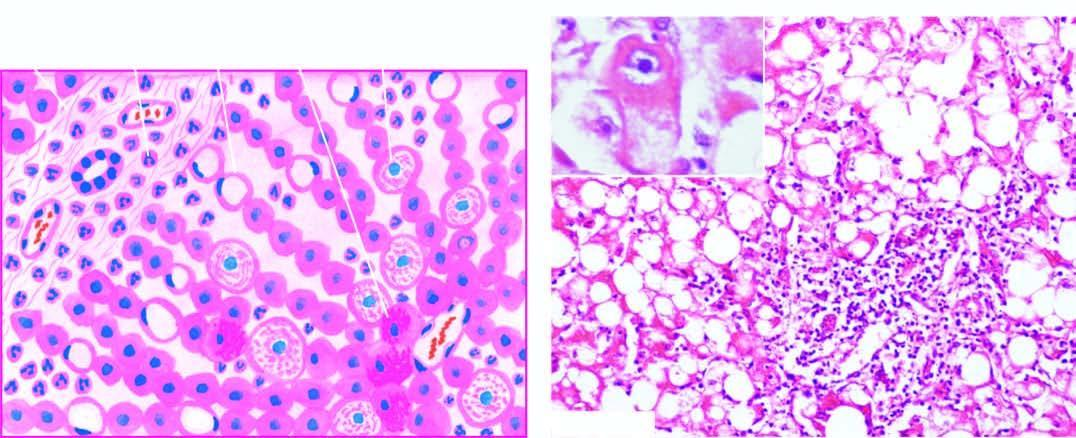what do liver cells show?
Answer the question using a single word or phrase. Ballooning degeneration and necrosis 